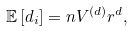<formula> <loc_0><loc_0><loc_500><loc_500>\mathbb { E } \left [ d _ { i } \right ] = n V ^ { \left ( d \right ) } r ^ { d } ,</formula> 